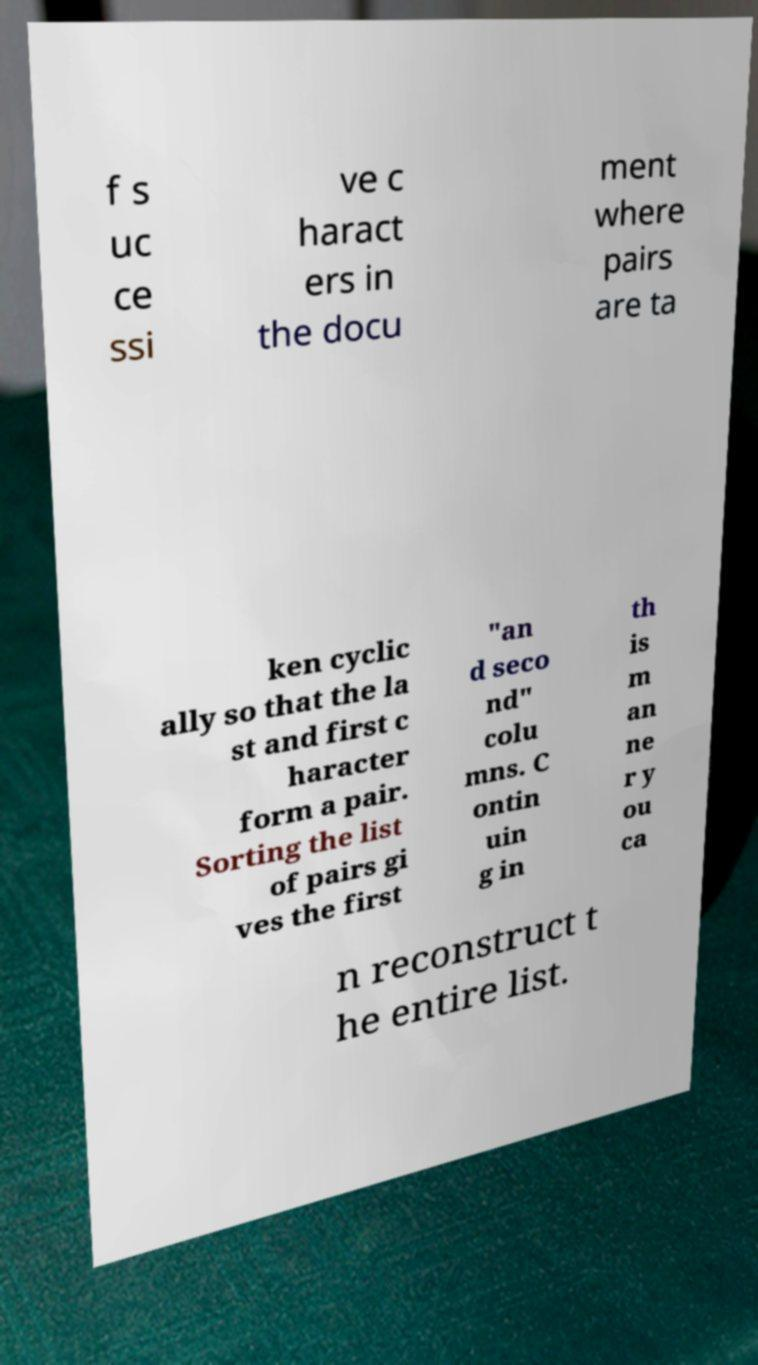What messages or text are displayed in this image? I need them in a readable, typed format. f s uc ce ssi ve c haract ers in the docu ment where pairs are ta ken cyclic ally so that the la st and first c haracter form a pair. Sorting the list of pairs gi ves the first "an d seco nd" colu mns. C ontin uin g in th is m an ne r y ou ca n reconstruct t he entire list. 